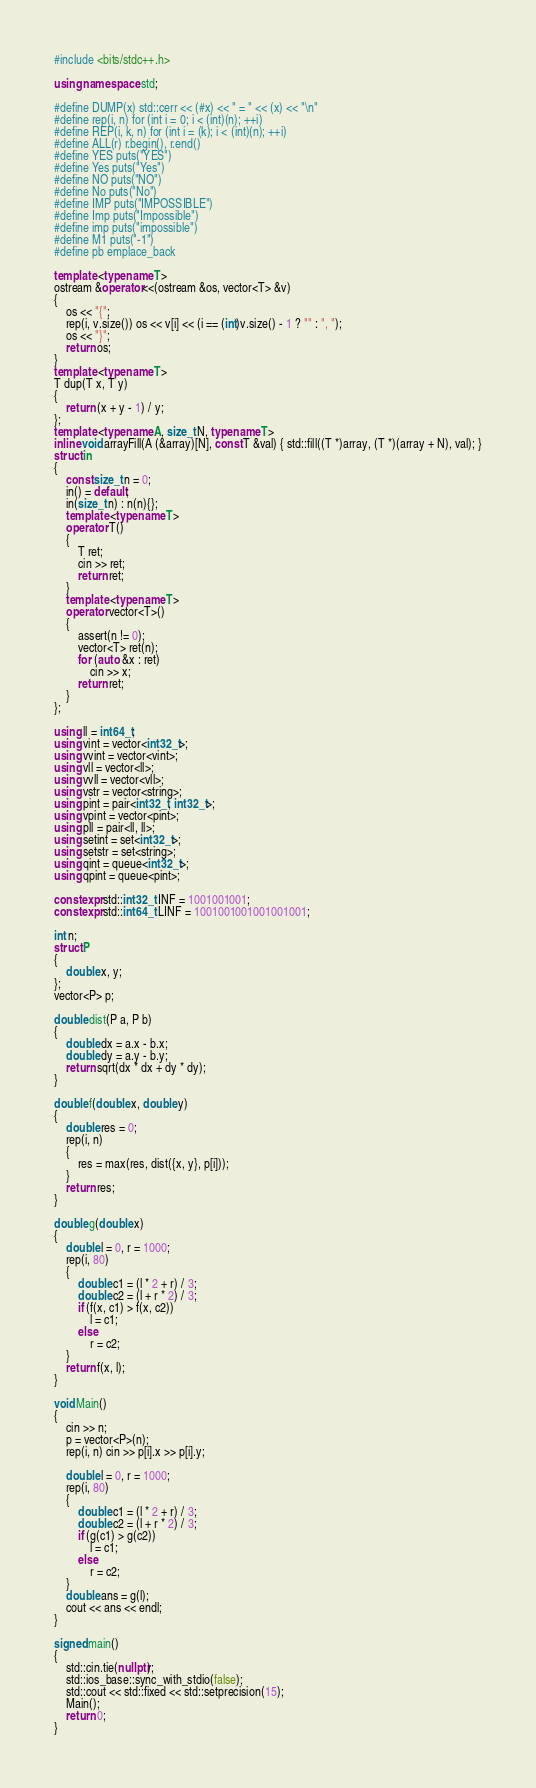<code> <loc_0><loc_0><loc_500><loc_500><_C++_>#include <bits/stdc++.h>

using namespace std;

#define DUMP(x) std::cerr << (#x) << " = " << (x) << "\n"
#define rep(i, n) for (int i = 0; i < (int)(n); ++i)
#define REP(i, k, n) for (int i = (k); i < (int)(n); ++i)
#define ALL(r) r.begin(), r.end()
#define YES puts("YES")
#define Yes puts("Yes")
#define NO puts("NO")
#define No puts("No")
#define IMP puts("IMPOSSIBLE")
#define Imp puts("Impossible")
#define imp puts("impossible")
#define M1 puts("-1")
#define pb emplace_back

template <typename T>
ostream &operator<<(ostream &os, vector<T> &v)
{
    os << "{";
    rep(i, v.size()) os << v[i] << (i == (int)v.size() - 1 ? "" : ", ");
    os << "}";
    return os;
}
template <typename T>
T dup(T x, T y)
{
    return (x + y - 1) / y;
};
template <typename A, size_t N, typename T>
inline void arrayFill(A (&array)[N], const T &val) { std::fill((T *)array, (T *)(array + N), val); }
struct in
{
    const size_t n = 0;
    in() = default;
    in(size_t n) : n(n){};
    template <typename T>
    operator T()
    {
        T ret;
        cin >> ret;
        return ret;
    }
    template <typename T>
    operator vector<T>()
    {
        assert(n != 0);
        vector<T> ret(n);
        for (auto &x : ret)
            cin >> x;
        return ret;
    }
};

using ll = int64_t;
using vint = vector<int32_t>;
using vvint = vector<vint>;
using vll = vector<ll>;
using vvll = vector<vll>;
using vstr = vector<string>;
using pint = pair<int32_t, int32_t>;
using vpint = vector<pint>;
using pll = pair<ll, ll>;
using setint = set<int32_t>;
using setstr = set<string>;
using qint = queue<int32_t>;
using qpint = queue<pint>;

constexpr std::int32_t INF = 1001001001;
constexpr std::int64_t LINF = 1001001001001001001;

int n;
struct P
{
    double x, y;
};
vector<P> p;

double dist(P a, P b)
{
    double dx = a.x - b.x;
    double dy = a.y - b.y;
    return sqrt(dx * dx + dy * dy);
}

double f(double x, double y)
{
    double res = 0;
    rep(i, n)
    {
        res = max(res, dist({x, y}, p[i]));
    }
    return res;
}

double g(double x)
{
    double l = 0, r = 1000;
    rep(i, 80)
    {
        double c1 = (l * 2 + r) / 3;
        double c2 = (l + r * 2) / 3;
        if (f(x, c1) > f(x, c2))
            l = c1;
        else
            r = c2;
    }
    return f(x, l);
}

void Main()
{
    cin >> n;
    p = vector<P>(n);
    rep(i, n) cin >> p[i].x >> p[i].y;

    double l = 0, r = 1000;
    rep(i, 80)
    {
        double c1 = (l * 2 + r) / 3;
        double c2 = (l + r * 2) / 3;
        if (g(c1) > g(c2))
            l = c1;
        else
            r = c2;
    }
    double ans = g(l);
    cout << ans << endl;
}

signed main()
{
    std::cin.tie(nullptr);
    std::ios_base::sync_with_stdio(false);
    std::cout << std::fixed << std::setprecision(15);
    Main();
    return 0;
}
</code> 